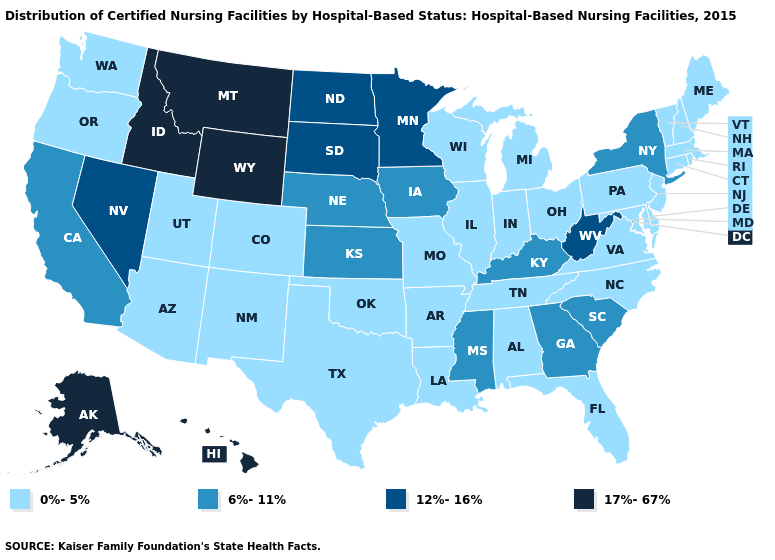Is the legend a continuous bar?
Short answer required. No. Name the states that have a value in the range 6%-11%?
Write a very short answer. California, Georgia, Iowa, Kansas, Kentucky, Mississippi, Nebraska, New York, South Carolina. What is the lowest value in the USA?
Concise answer only. 0%-5%. Name the states that have a value in the range 17%-67%?
Quick response, please. Alaska, Hawaii, Idaho, Montana, Wyoming. What is the value of Florida?
Answer briefly. 0%-5%. Does New Jersey have the same value as Georgia?
Write a very short answer. No. Does Texas have the highest value in the South?
Write a very short answer. No. Does the first symbol in the legend represent the smallest category?
Answer briefly. Yes. Name the states that have a value in the range 17%-67%?
Be succinct. Alaska, Hawaii, Idaho, Montana, Wyoming. Name the states that have a value in the range 6%-11%?
Answer briefly. California, Georgia, Iowa, Kansas, Kentucky, Mississippi, Nebraska, New York, South Carolina. Name the states that have a value in the range 6%-11%?
Short answer required. California, Georgia, Iowa, Kansas, Kentucky, Mississippi, Nebraska, New York, South Carolina. Among the states that border Oregon , does Nevada have the highest value?
Quick response, please. No. What is the value of Rhode Island?
Give a very brief answer. 0%-5%. What is the lowest value in the South?
Be succinct. 0%-5%. Name the states that have a value in the range 17%-67%?
Concise answer only. Alaska, Hawaii, Idaho, Montana, Wyoming. 